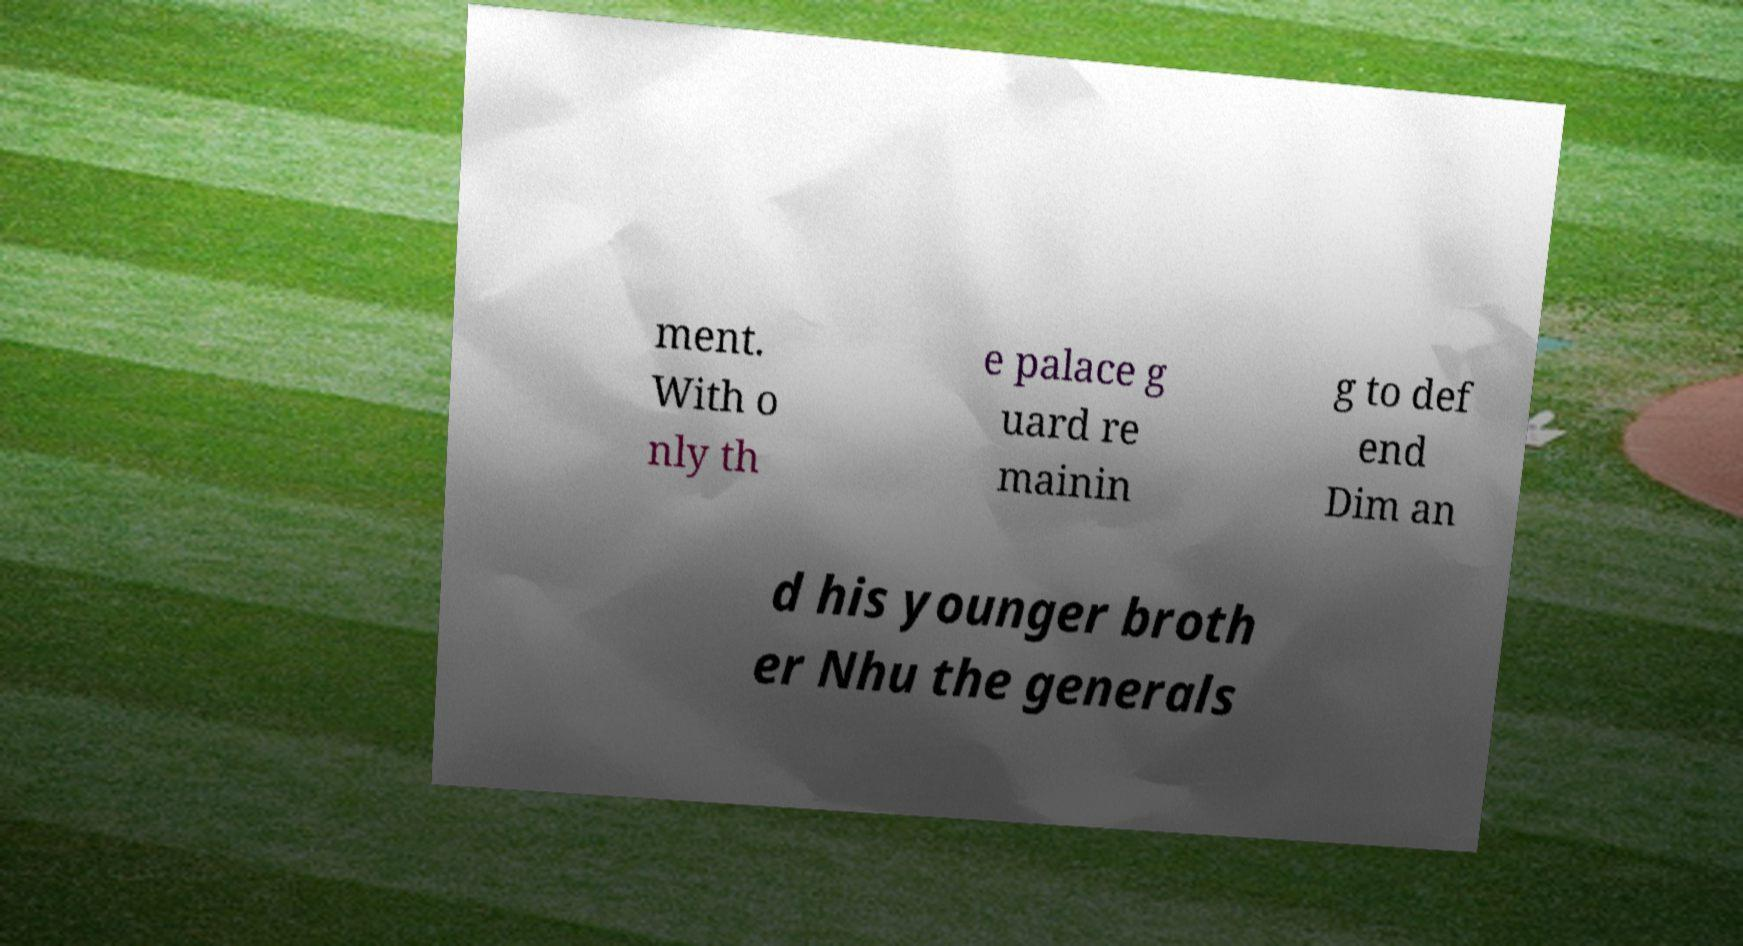Please read and relay the text visible in this image. What does it say? ment. With o nly th e palace g uard re mainin g to def end Dim an d his younger broth er Nhu the generals 